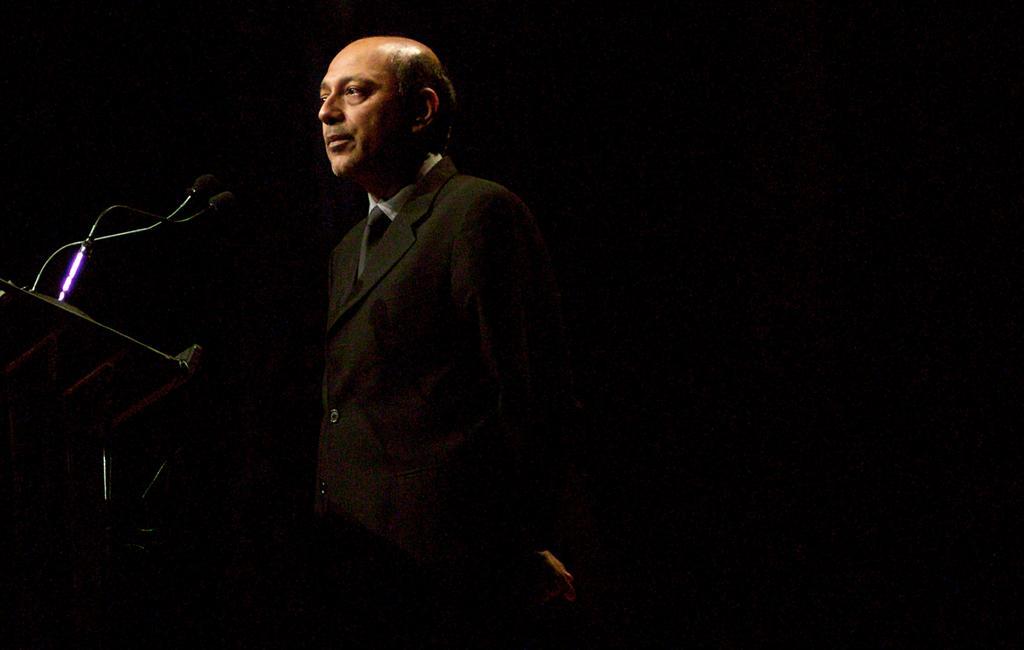Could you give a brief overview of what you see in this image? In this image I can see a person standing, wearing a suit. There are microphones and its stand in front of him. There is a black background. 